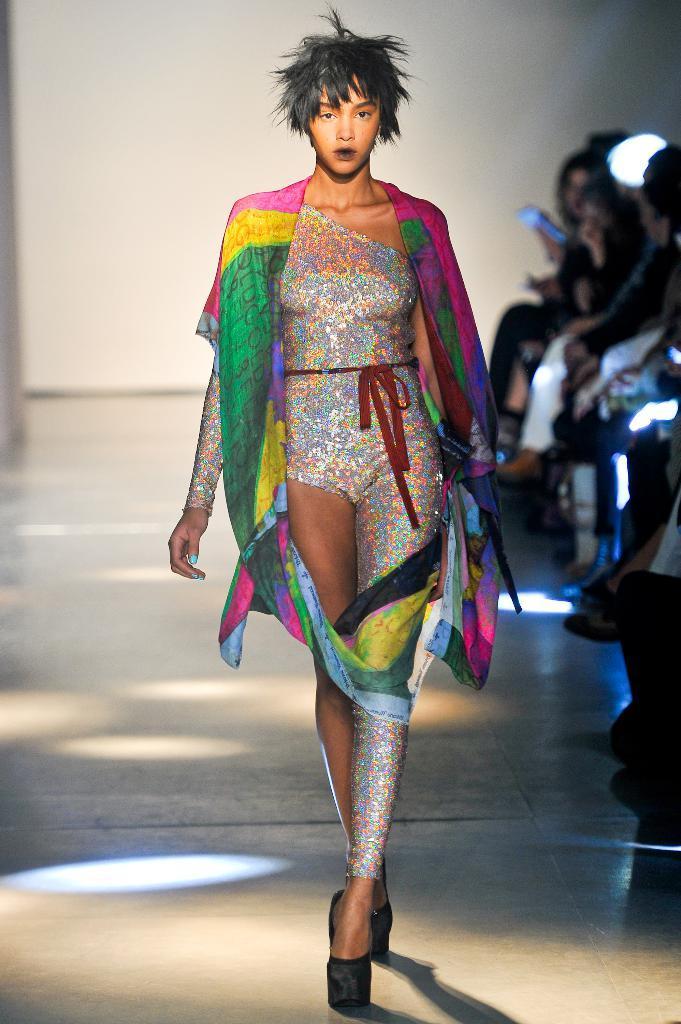In one or two sentences, can you explain what this image depicts? In this picture there is a woman walking on the floor. In the background of the image it is blurry and we can see people. 